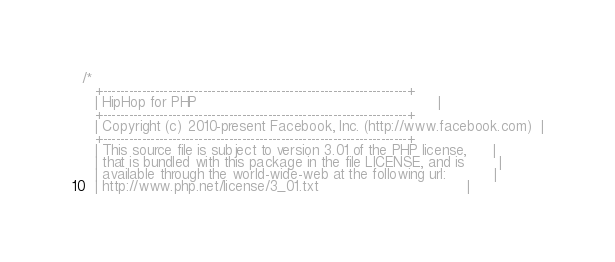<code> <loc_0><loc_0><loc_500><loc_500><_C_>/*
   +----------------------------------------------------------------------+
   | HipHop for PHP                                                       |
   +----------------------------------------------------------------------+
   | Copyright (c) 2010-present Facebook, Inc. (http://www.facebook.com)  |
   +----------------------------------------------------------------------+
   | This source file is subject to version 3.01 of the PHP license,      |
   | that is bundled with this package in the file LICENSE, and is        |
   | available through the world-wide-web at the following url:           |
   | http://www.php.net/license/3_01.txt                                  |</code> 